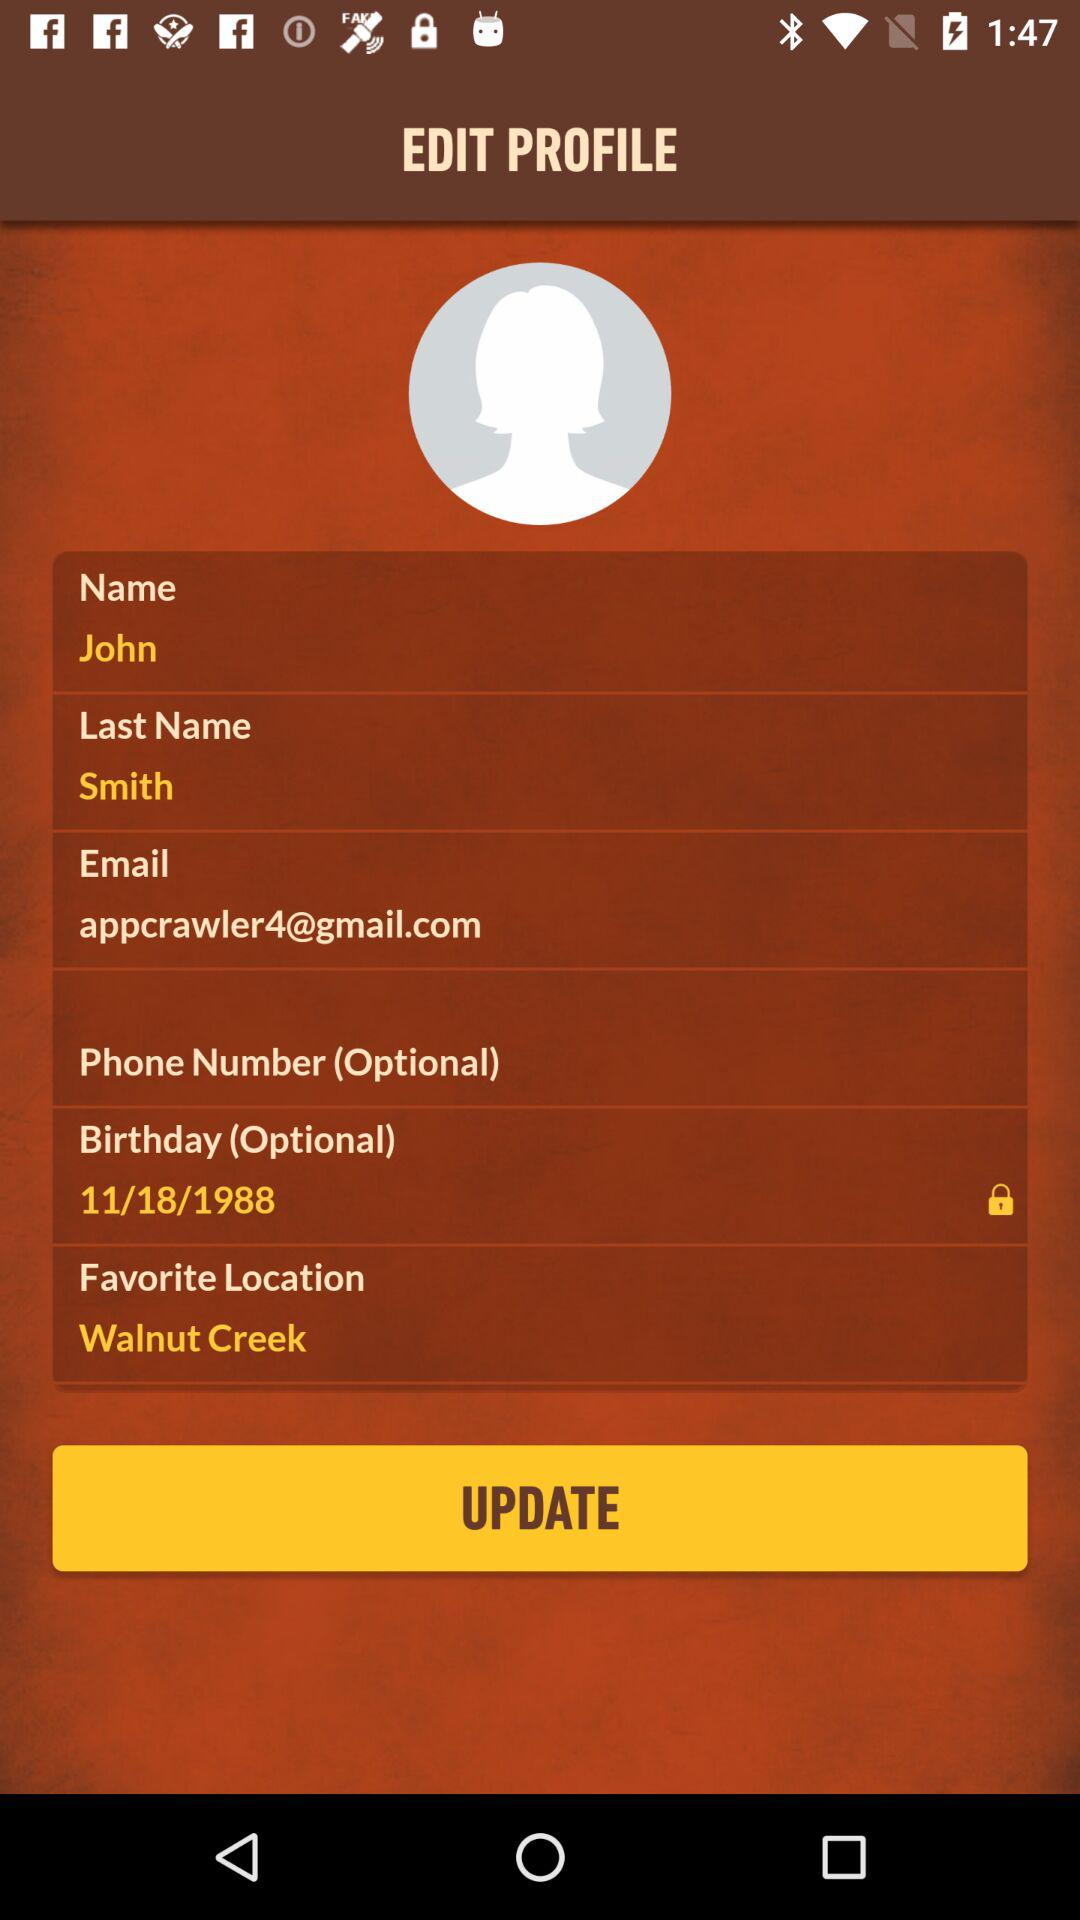What profile field is shown locked? The profile field that is shown locked is "Birthday (Optional)". 